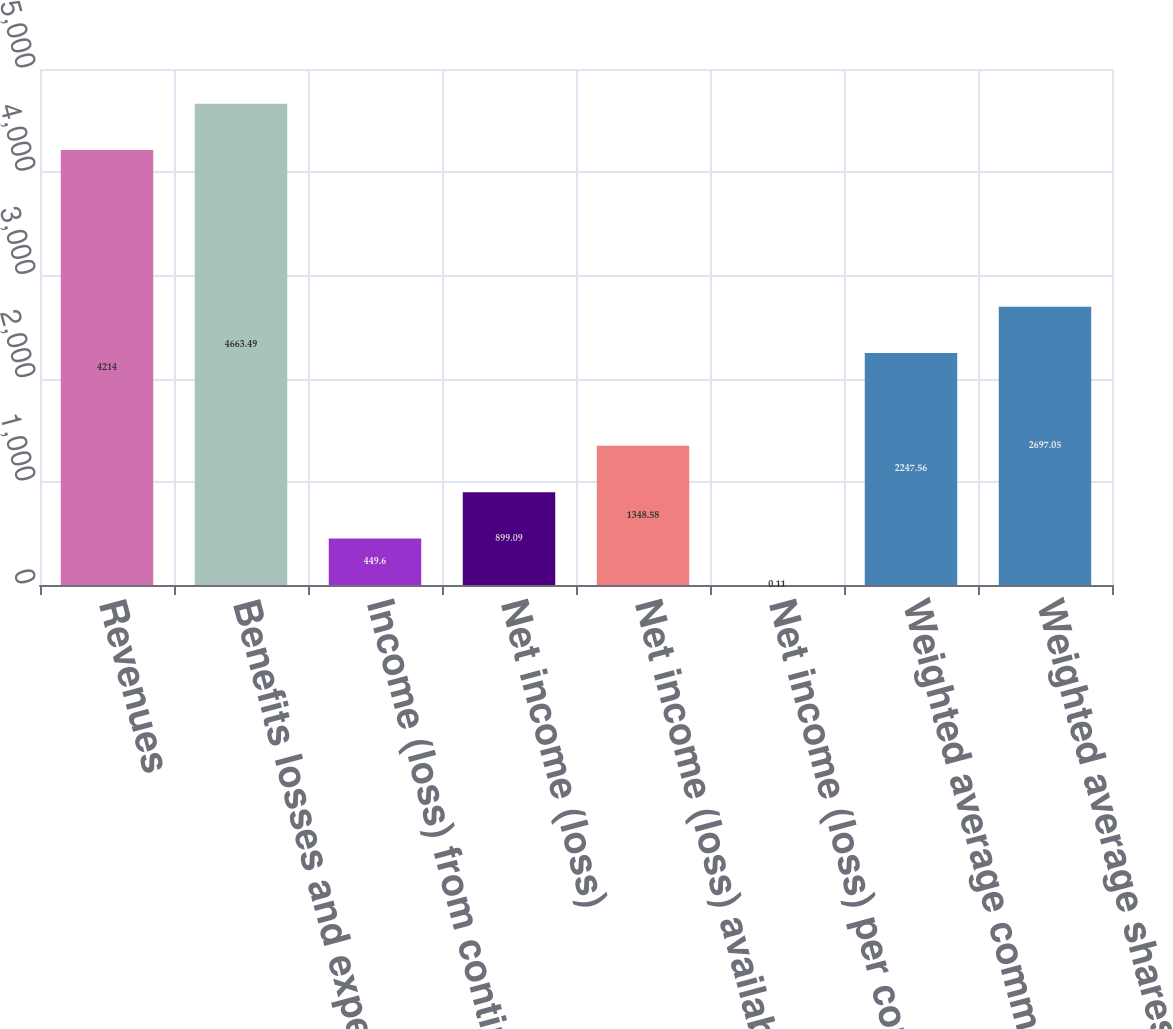<chart> <loc_0><loc_0><loc_500><loc_500><bar_chart><fcel>Revenues<fcel>Benefits losses and expenses<fcel>Income (loss) from continuing<fcel>Net income (loss)<fcel>Net income (loss) available to<fcel>Net income (loss) per common<fcel>Weighted average common shares<fcel>Weighted average shares<nl><fcel>4214<fcel>4663.49<fcel>449.6<fcel>899.09<fcel>1348.58<fcel>0.11<fcel>2247.56<fcel>2697.05<nl></chart> 